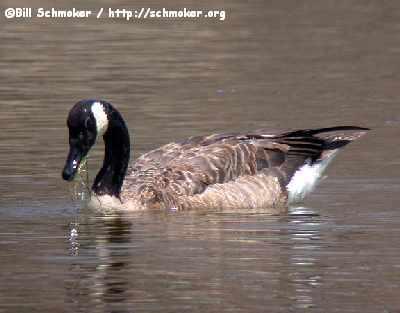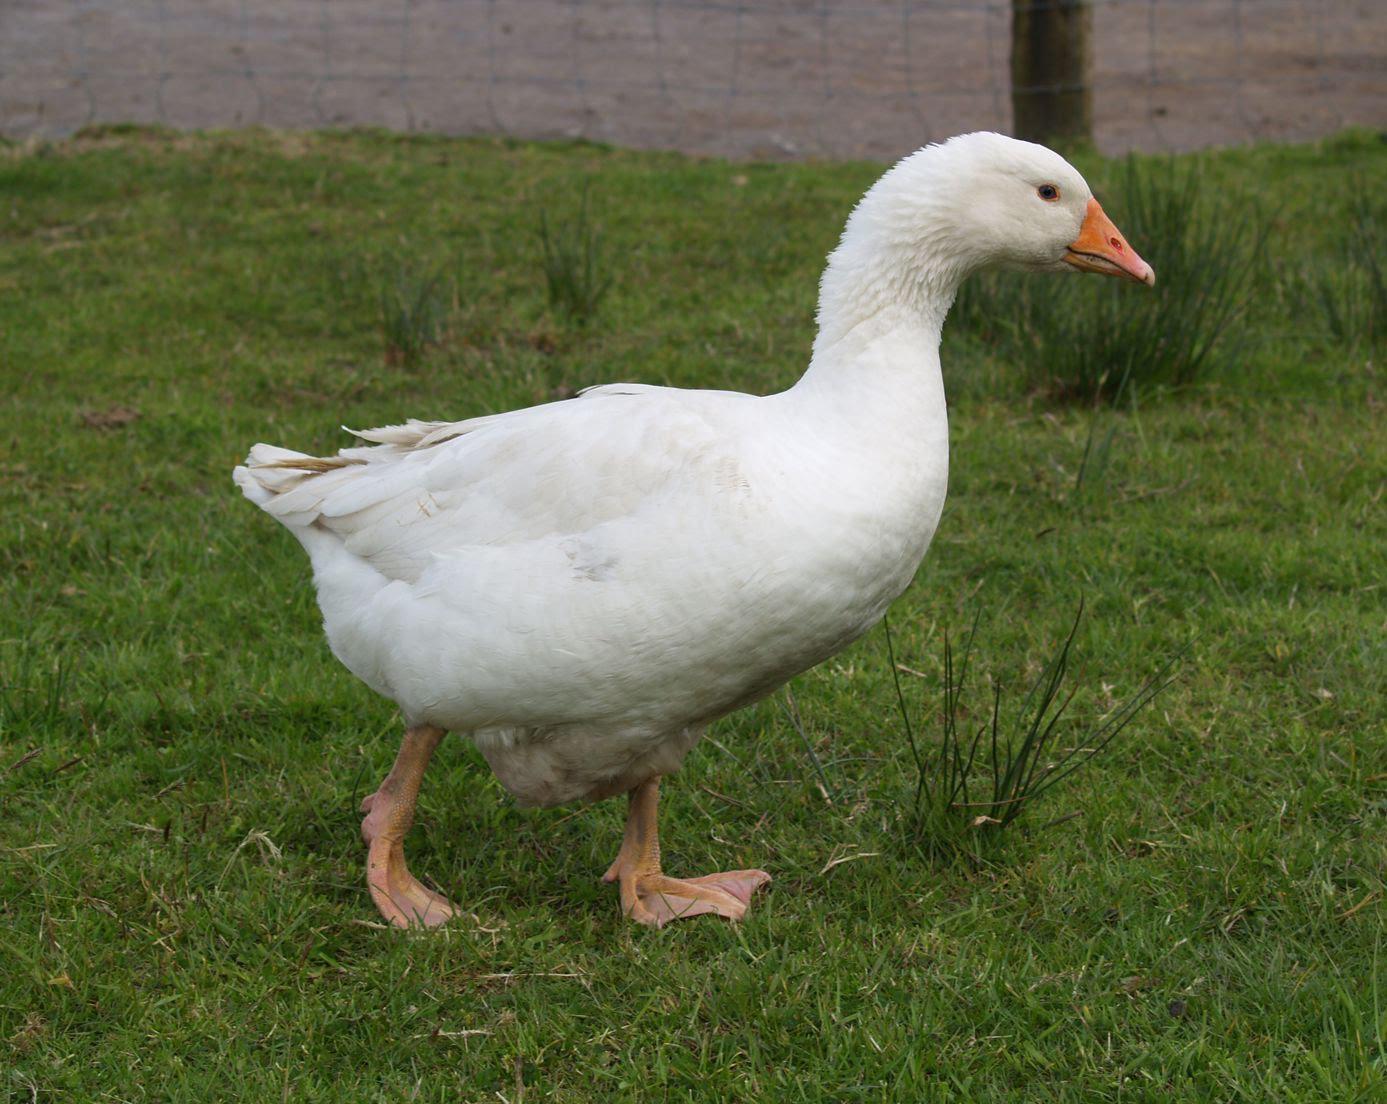The first image is the image on the left, the second image is the image on the right. Given the left and right images, does the statement "One image shows black-necked Canadian geese standing in shallow water, and the other image includes a white duck eating something." hold true? Answer yes or no. No. The first image is the image on the left, the second image is the image on the right. Given the left and right images, does the statement "An image contains no more than one white duck." hold true? Answer yes or no. Yes. 